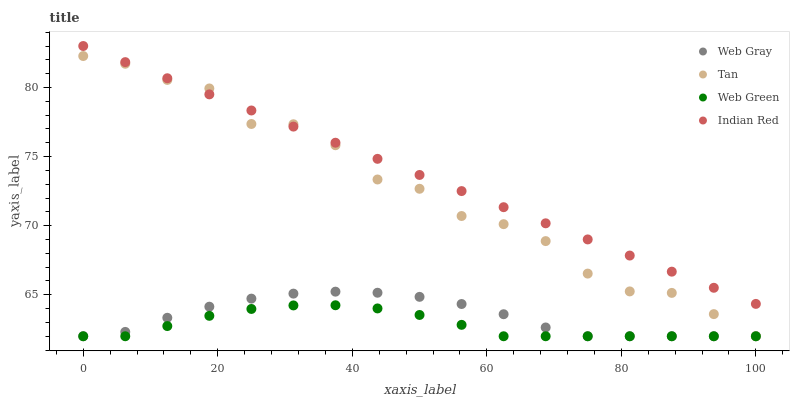Does Web Green have the minimum area under the curve?
Answer yes or no. Yes. Does Indian Red have the maximum area under the curve?
Answer yes or no. Yes. Does Web Gray have the minimum area under the curve?
Answer yes or no. No. Does Web Gray have the maximum area under the curve?
Answer yes or no. No. Is Indian Red the smoothest?
Answer yes or no. Yes. Is Tan the roughest?
Answer yes or no. Yes. Is Web Gray the smoothest?
Answer yes or no. No. Is Web Gray the roughest?
Answer yes or no. No. Does Tan have the lowest value?
Answer yes or no. Yes. Does Indian Red have the lowest value?
Answer yes or no. No. Does Indian Red have the highest value?
Answer yes or no. Yes. Does Web Gray have the highest value?
Answer yes or no. No. Is Web Gray less than Indian Red?
Answer yes or no. Yes. Is Indian Red greater than Web Gray?
Answer yes or no. Yes. Does Web Gray intersect Tan?
Answer yes or no. Yes. Is Web Gray less than Tan?
Answer yes or no. No. Is Web Gray greater than Tan?
Answer yes or no. No. Does Web Gray intersect Indian Red?
Answer yes or no. No. 